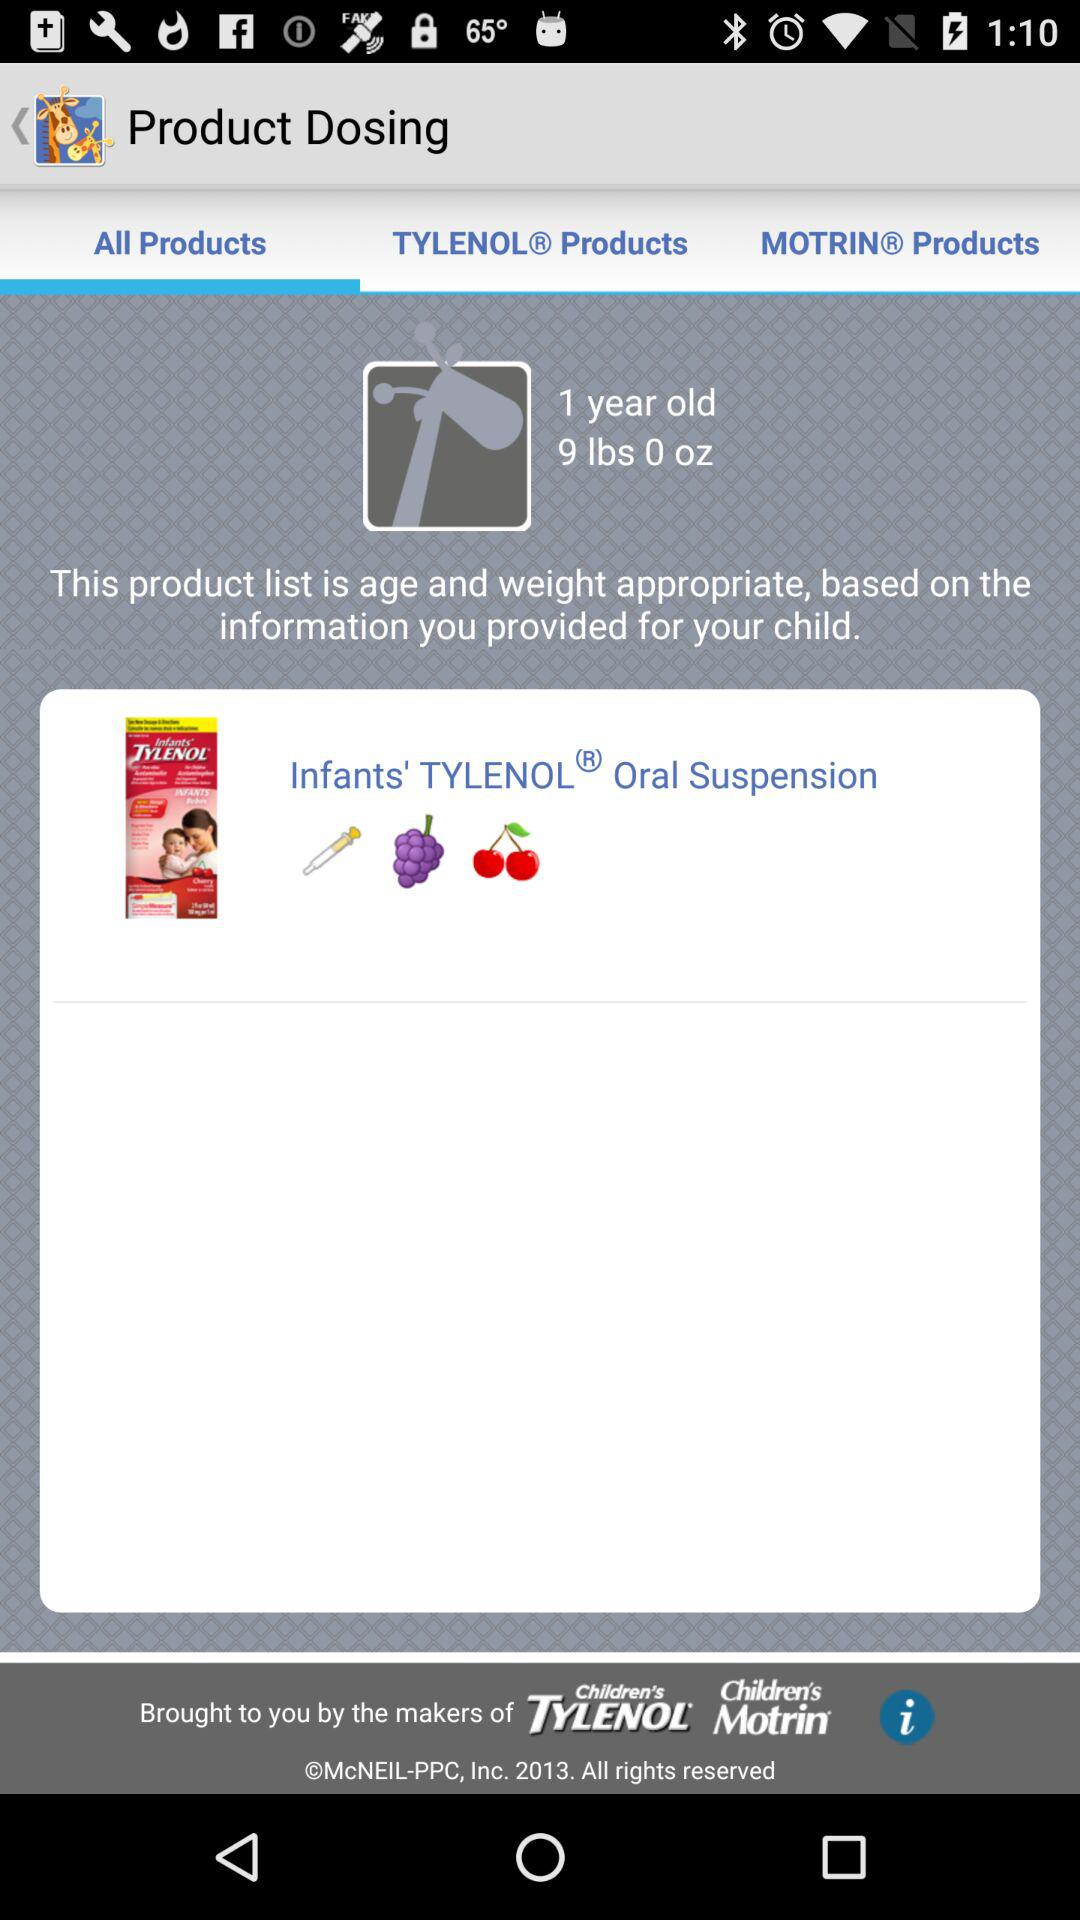How many years old is the child? The child is 1 year old. 